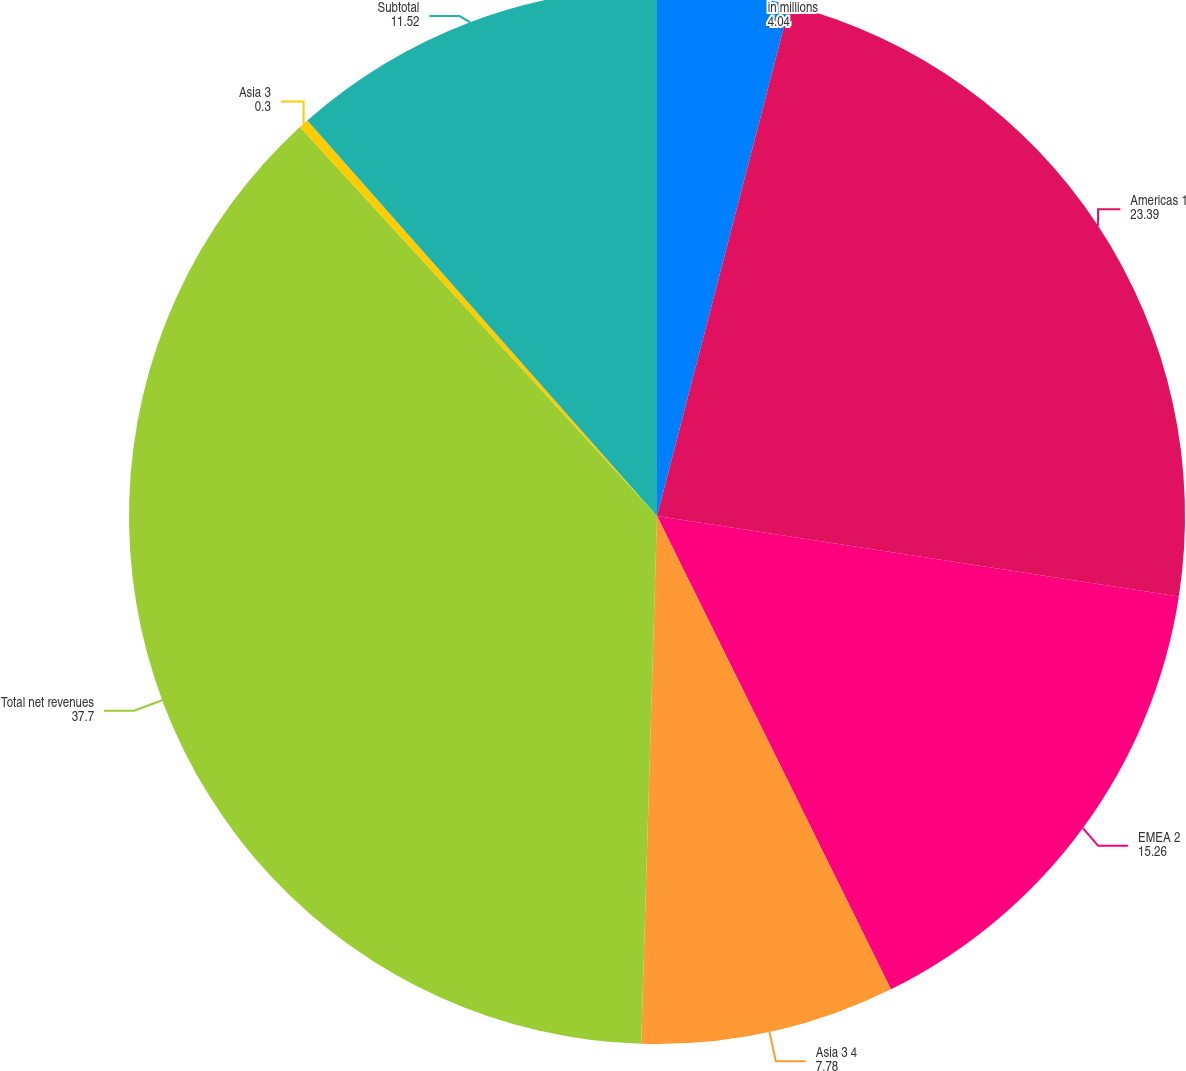Convert chart to OTSL. <chart><loc_0><loc_0><loc_500><loc_500><pie_chart><fcel>in millions<fcel>Americas 1<fcel>EMEA 2<fcel>Asia 3 4<fcel>Total net revenues<fcel>Asia 3<fcel>Subtotal<nl><fcel>4.04%<fcel>23.39%<fcel>15.26%<fcel>7.78%<fcel>37.7%<fcel>0.3%<fcel>11.52%<nl></chart> 